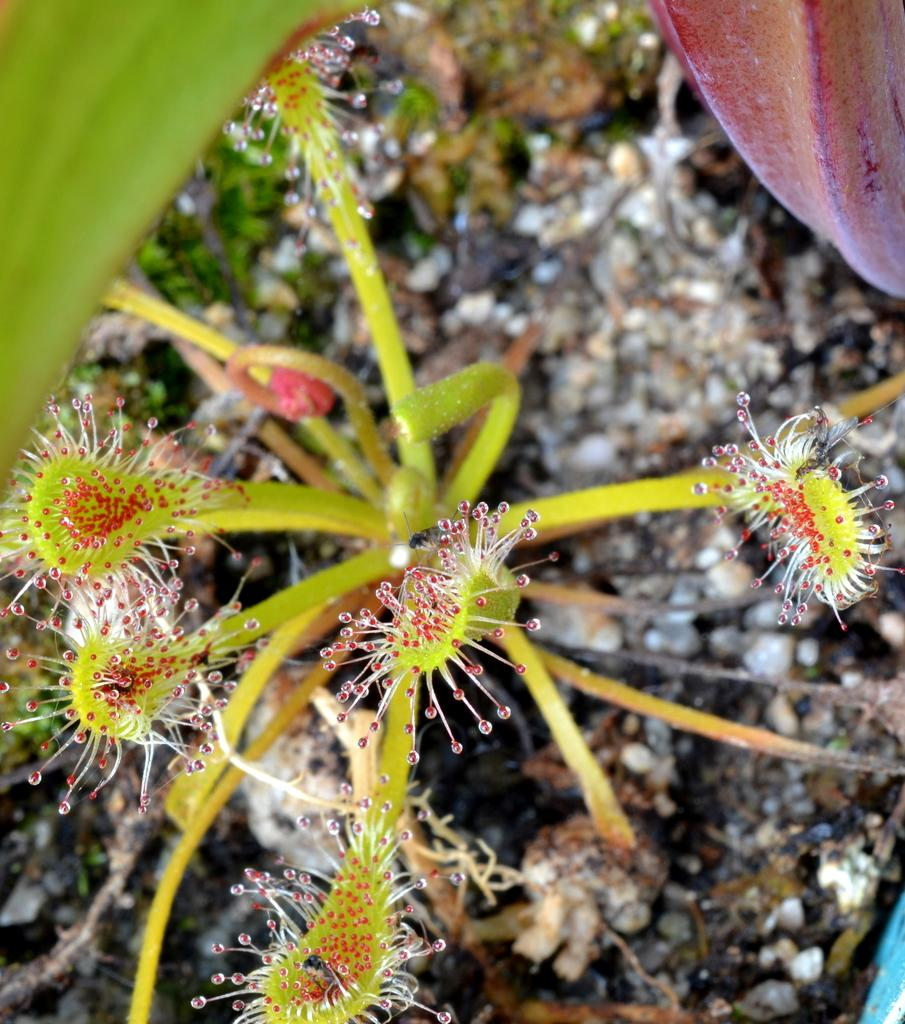What is located in the foreground of the image? There is a plant in the foreground of the image. What can be seen in the background of the image? There is scrap in the background of the image. What part of the plant is visible in the image? There are leaves visible at the top of the image. How many drops of water can be seen falling from the plant's mouth in the image? There is no plant with a mouth present in the image, and therefore no drops of water can be seen falling from it. 